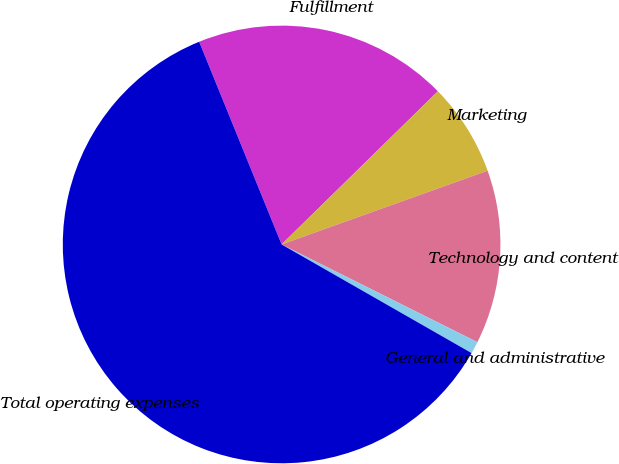Convert chart. <chart><loc_0><loc_0><loc_500><loc_500><pie_chart><fcel>Fulfillment<fcel>Marketing<fcel>Technology and content<fcel>General and administrative<fcel>Total operating expenses<nl><fcel>18.81%<fcel>6.87%<fcel>12.84%<fcel>0.9%<fcel>60.59%<nl></chart> 